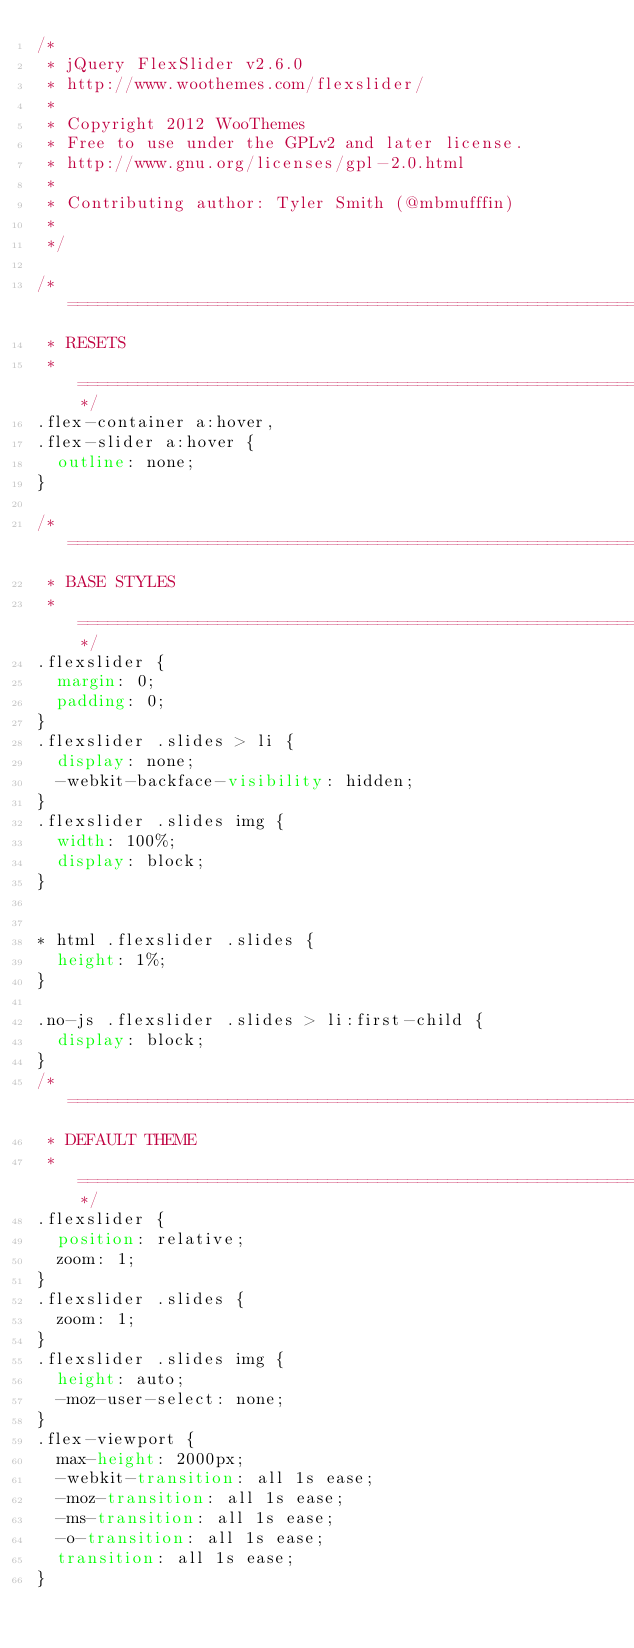Convert code to text. <code><loc_0><loc_0><loc_500><loc_500><_CSS_>/*
 * jQuery FlexSlider v2.6.0
 * http://www.woothemes.com/flexslider/
 *
 * Copyright 2012 WooThemes
 * Free to use under the GPLv2 and later license.
 * http://www.gnu.org/licenses/gpl-2.0.html
 *
 * Contributing author: Tyler Smith (@mbmufffin)
 *
 */

/* ====================================================================================================================
 * RESETS
 * ====================================================================================================================*/
.flex-container a:hover,
.flex-slider a:hover {
  outline: none;
}

/* ====================================================================================================================
 * BASE STYLES
 * ====================================================================================================================*/
.flexslider {
  margin: 0;
  padding: 0;
}
.flexslider .slides > li {
  display: none;
  -webkit-backface-visibility: hidden;
}
.flexslider .slides img {
  width: 100%;
  display: block;
}


* html .flexslider .slides {
  height: 1%;
}

.no-js .flexslider .slides > li:first-child {
  display: block;
}
/* ====================================================================================================================
 * DEFAULT THEME
 * ====================================================================================================================*/
.flexslider {
  position: relative;
  zoom: 1;
}
.flexslider .slides {
  zoom: 1;
}
.flexslider .slides img {
  height: auto;
  -moz-user-select: none;
}
.flex-viewport {
  max-height: 2000px;
  -webkit-transition: all 1s ease;
  -moz-transition: all 1s ease;
  -ms-transition: all 1s ease;
  -o-transition: all 1s ease;
  transition: all 1s ease;
}
</code> 